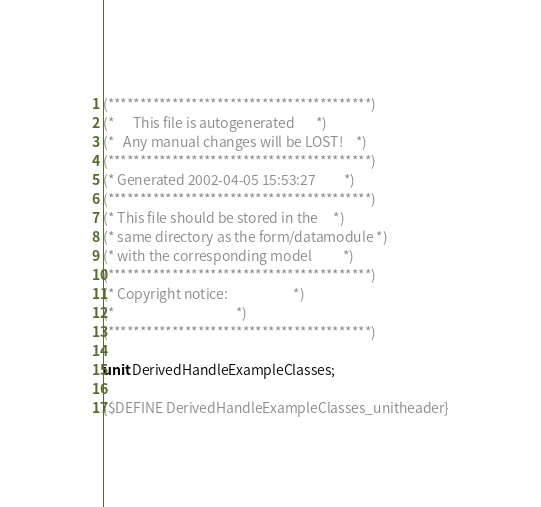<code> <loc_0><loc_0><loc_500><loc_500><_Pascal_>(*****************************************)
(*      This file is autogenerated       *)
(*   Any manual changes will be LOST!    *)
(*****************************************)
(* Generated 2002-04-05 15:53:27         *)
(*****************************************)
(* This file should be stored in the     *)
(* same directory as the form/datamodule *)
(* with the corresponding model          *)
(*****************************************)
(* Copyright notice:                     *)
(*                                       *)
(*****************************************)

unit DerivedHandleExampleClasses;

{$DEFINE DerivedHandleExampleClasses_unitheader}</code> 